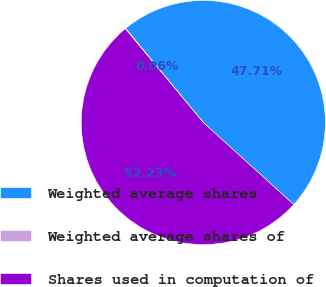Convert chart to OTSL. <chart><loc_0><loc_0><loc_500><loc_500><pie_chart><fcel>Weighted average shares<fcel>Weighted average shares of<fcel>Shares used in computation of<nl><fcel>47.71%<fcel>0.06%<fcel>52.23%<nl></chart> 